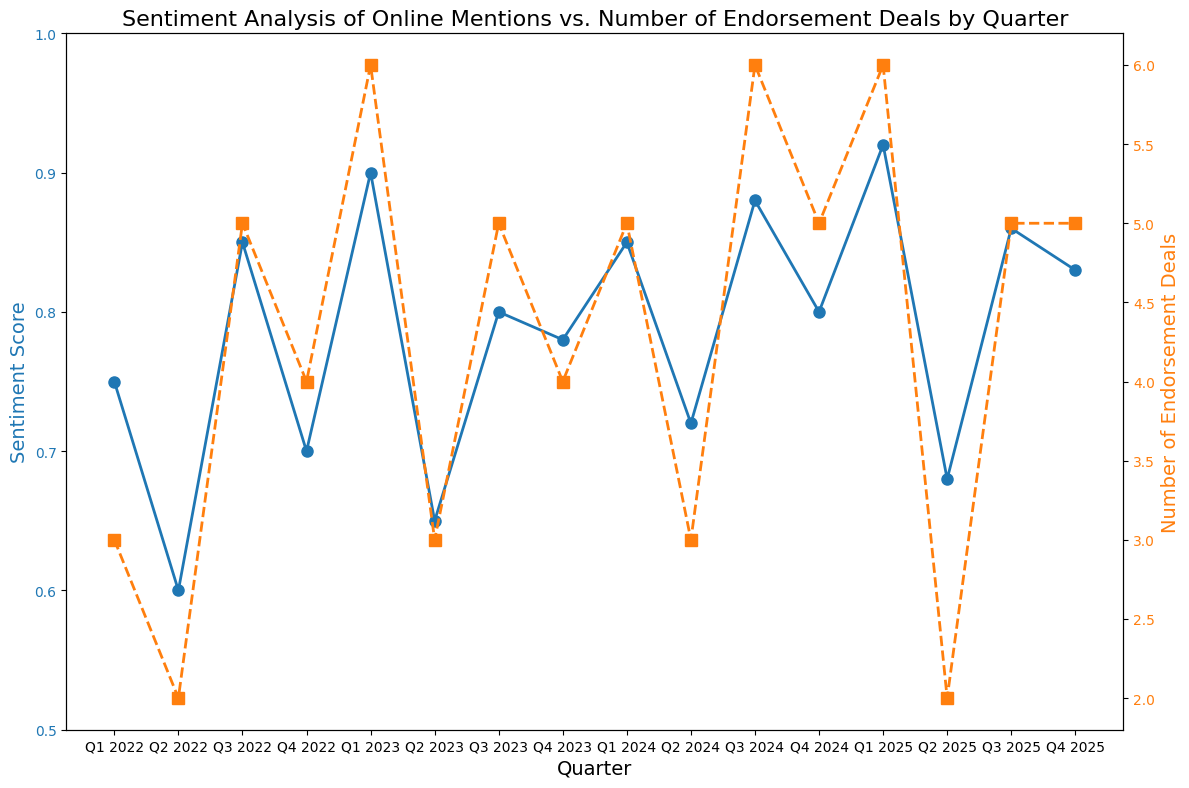Which quarter had the highest Sentiment Score? The highest Sentiment Score can be identified by finding the tallest data points in the blue line representing Sentiment Scores.
Answer: Q1 2025 Which quarter saw the lowest number of Endorsement Deals? The lowest number of Endorsement Deals can be identified by finding the shortest data points in the orange line representing these deals.
Answer: Q2 2025 During which quarters did both Sentiment Score and Number of Endorsement Deals increase compared to the previous quarter? To find this, look for quarters where both blue and orange lines increase from the previous point. These would be quarters where there is an upward trend for both datasets.
Answer: Q3 2022, Q1 2023, Q3 2024, Q1 2025 What is the average Sentiment Score for the year 2024? Sum the Sentiment Scores for Q1 2024, Q2 2024, Q3 2024, and Q4 2024, then divide by 4. (0.85 + 0.72 + 0.88 + 0.80) / 4
Answer: 0.8125 Compare the Sentiment Score in Q3 2025 and Q4 2025. Which is higher? Locate the blue data points for Q3 2025 and Q4 2025 and compare their heights.
Answer: Q3 2025 What is the difference between the number of Endorsement Deals in Q3 2023 and Q4 2023? Find the Number of Endorsement Deals for both quarters and subtract Q4 2023 from Q3 2023: 5 - 4
Answer: 1 How do the trends of Sentiment Scores and Number of Endorsement Deals compare between Q1 2022 and Q4 2022? Observe both the blue and orange lines from Q1 2022 to Q4 2022 to identify if they show an increasing, decreasing, or stable pattern.
Answer: Sentiment Scores decrease then increase; Number of Endorsement Deals are variable but no straight trend How many quarters show a decline in Sentiment Score just before a peak in the next quarter? Look for quarters where a dip in the blue line is immediately followed by a peak in the next quarter's blue data point.
Answer: 4 (Q2 2022 to Q3 2022, Q4 2022 to Q1 2023, Q2 2023 to Q3 2023, Q1 2024 to Q2 2024) What is the change in the number of Endorsement Deals from Q2 2022 to Q3 2022? Subtract the Number of Endorsement Deals in Q2 2022 from Q3 2022: 5 - 2
Answer: 3 